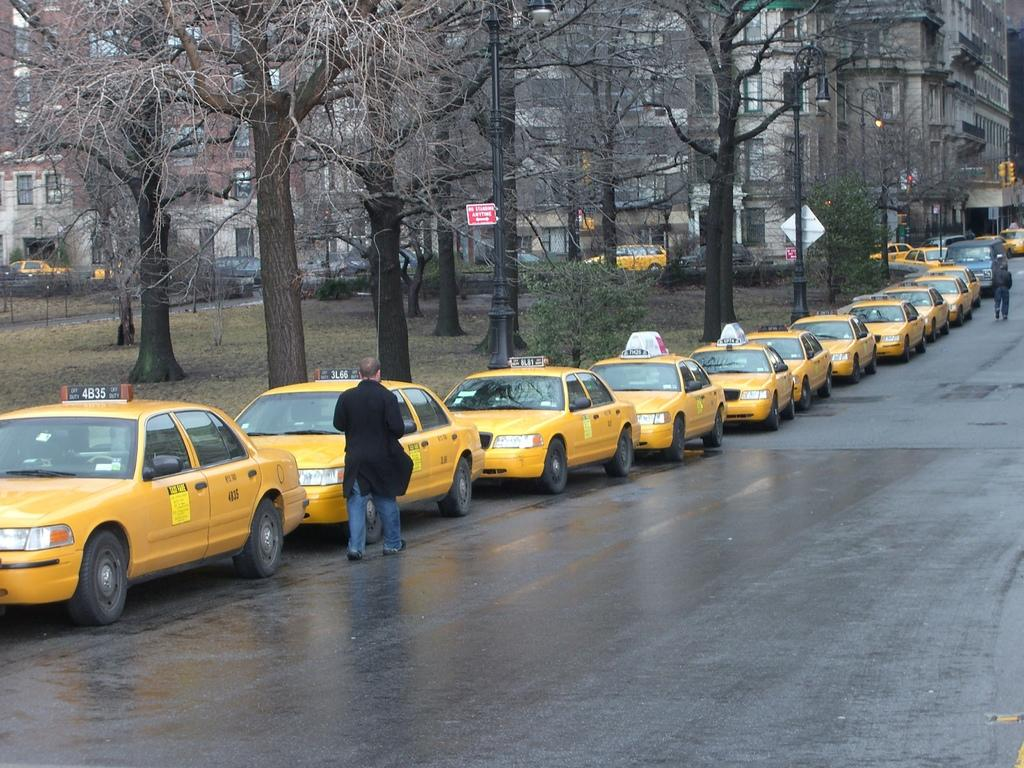What can be seen beside the road in the image? There are many cars parked beside the road. What type of vegetation is present beside the parked cars? There are trees and grass beside the parked cars. What structures are visible behind the trees? There are big buildings behind the trees. Can any cars be seen behind the trees? Yes, there are some cars visible behind the trees. What type of stone is being used to support the leg of the car in the image? There is no car with a leg in the image, and therefore no stone is being used to support it. 